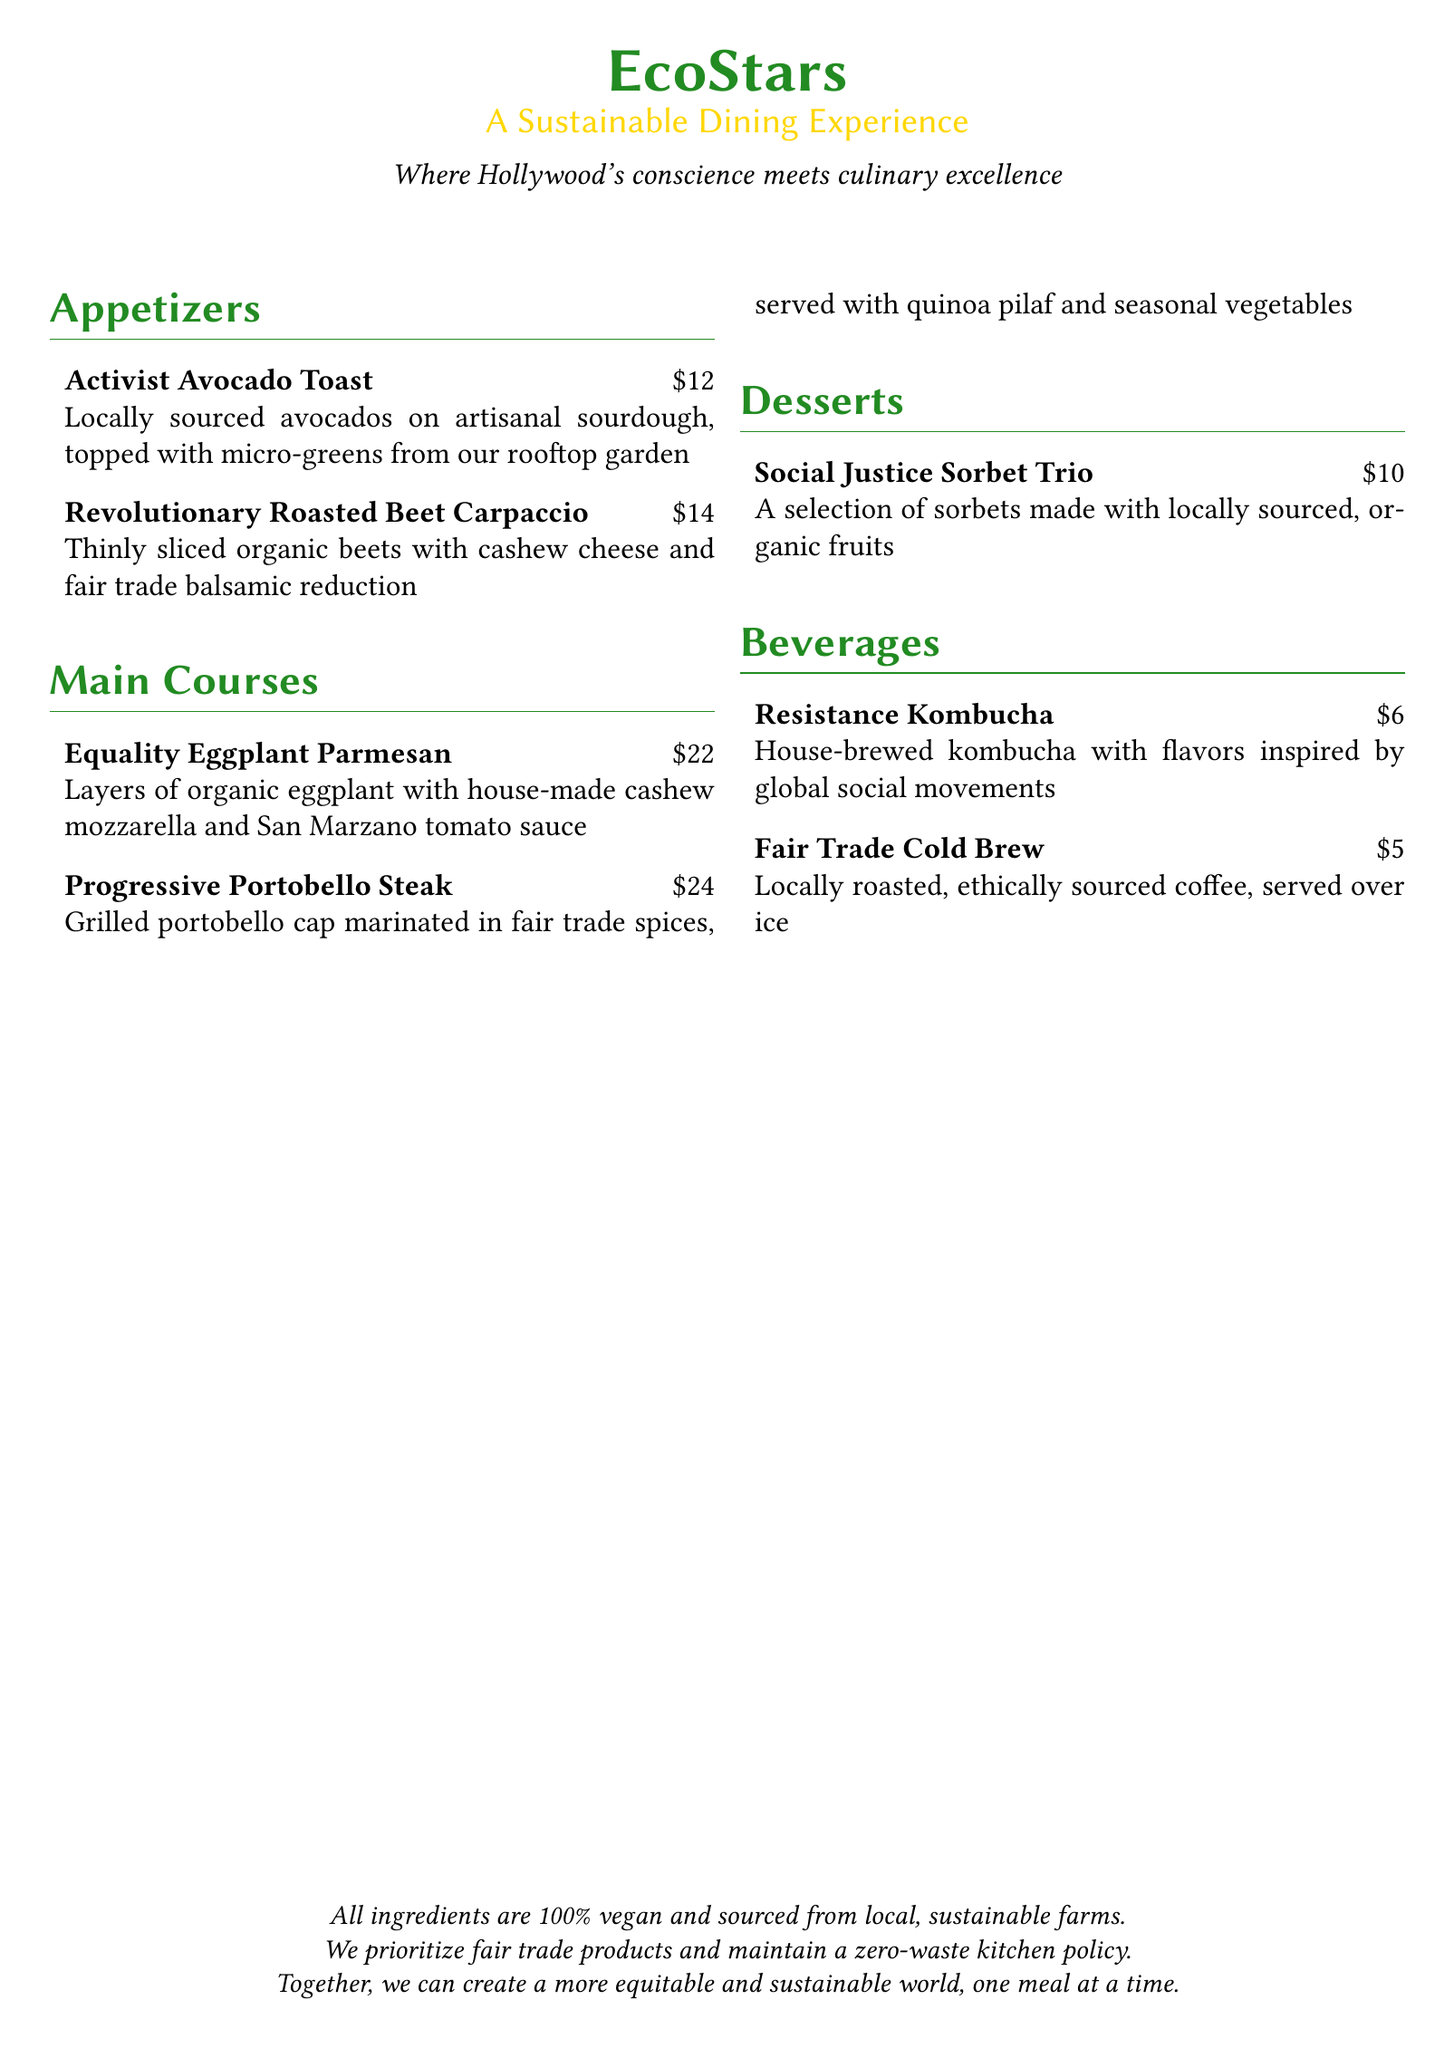what is the price of the Activist Avocado Toast? The price of the Activist Avocado Toast is listed under appetizers in the document, which is $12.
Answer: $12 how many main courses are there? The document lists two main courses under the main courses section.
Answer: 2 what type of cheese is in the Revolutionary Roasted Beet Carpaccio? The type of cheese mentioned in the Revolutionary Roasted Beet Carpaccio is cashew cheese.
Answer: cashew cheese what main ingredient is featured in the Equality Eggplant Parmesan? The main ingredient featured in the Equality Eggplant Parmesan is organic eggplant.
Answer: organic eggplant what flavor does the Resistance Kombucha draw inspiration from? The document states that the flavor is inspired by global social movements, which indicates the thematic focus.
Answer: global social movements what is the total number of appetizers listed? The document explicitly lists two appetizers under the appetizers section, counting both items mentioned.
Answer: 2 what are the desserts made from? The desserts are made with locally sourced, organic fruits as stated in the document.
Answer: locally sourced, organic fruits what policy does the restaurant maintain regarding kitchen waste? The document mentions that the restaurant maintains a zero-waste kitchen policy, indicating their sustainability efforts.
Answer: zero-waste kitchen policy 